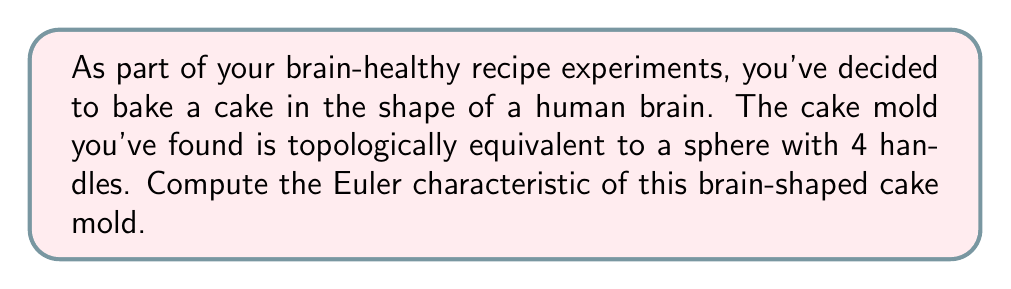Show me your answer to this math problem. To compute the Euler characteristic of the brain-shaped cake mold, we'll follow these steps:

1) Recall the Euler characteristic formula:
   $$\chi = V - E + F$$
   where $\chi$ is the Euler characteristic, $V$ is the number of vertices, $E$ is the number of edges, and $F$ is the number of faces.

2) For a sphere, the Euler characteristic is 2:
   $$\chi_{sphere} = 2$$

3) Each handle reduces the Euler characteristic by 2. This is because adding a handle is topologically equivalent to removing two disks from the surface and attaching a cylinder, which decreases $\chi$ by 2.

4) The brain-shaped mold has 4 handles, so we need to subtract 8 from the Euler characteristic of a sphere:
   $$\chi_{brain} = \chi_{sphere} - 4 * 2$$
   $$\chi_{brain} = 2 - 8 = -6$$

5) We can verify this using the genus of the surface. The genus $g$ of a surface is the number of handles, and for a closed orientable surface:
   $$\chi = 2 - 2g$$
   
   In this case, $g = 4$, so:
   $$\chi = 2 - 2(4) = 2 - 8 = -6$$

Therefore, the Euler characteristic of the brain-shaped cake mold is -6.
Answer: $\chi = -6$ 